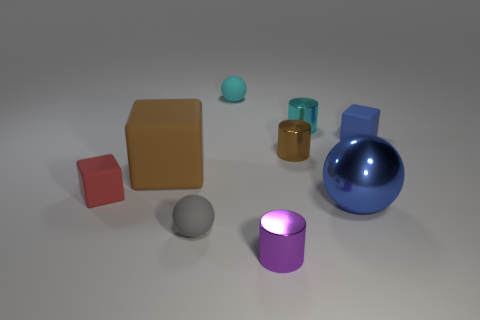There is a gray matte object in front of the blue sphere; is it the same shape as the tiny brown thing that is in front of the tiny blue rubber block?
Provide a short and direct response. No. What number of other things are there of the same material as the tiny blue cube
Keep it short and to the point. 4. The brown object that is the same material as the small red cube is what shape?
Your answer should be compact. Cube. Is the size of the red matte object the same as the purple metal thing?
Your answer should be compact. Yes. What is the size of the blue object behind the blue object that is left of the blue rubber thing?
Offer a terse response. Small. What shape is the tiny matte thing that is the same color as the large metal thing?
Give a very brief answer. Cube. How many cylinders are either big green metallic objects or blue shiny objects?
Your answer should be very brief. 0. Do the purple metallic object and the cube that is in front of the big matte object have the same size?
Your answer should be very brief. Yes. Are there more rubber cubes that are to the left of the large blue metallic thing than large blue metal cubes?
Your response must be concise. Yes. The blue cube that is the same material as the big brown cube is what size?
Your response must be concise. Small. 